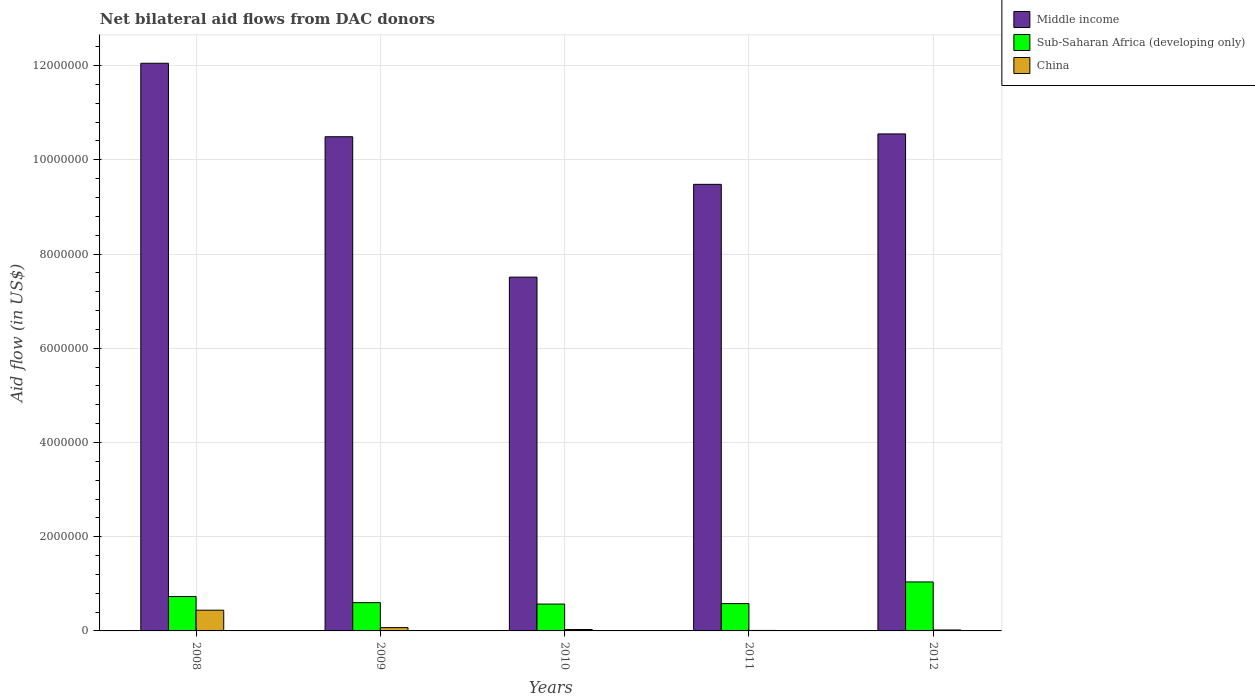Are the number of bars per tick equal to the number of legend labels?
Provide a short and direct response. Yes. Are the number of bars on each tick of the X-axis equal?
Ensure brevity in your answer.  Yes. How many bars are there on the 1st tick from the right?
Keep it short and to the point. 3. What is the label of the 4th group of bars from the left?
Provide a succinct answer. 2011. In how many cases, is the number of bars for a given year not equal to the number of legend labels?
Ensure brevity in your answer.  0. What is the net bilateral aid flow in Middle income in 2012?
Provide a succinct answer. 1.06e+07. Across all years, what is the maximum net bilateral aid flow in Middle income?
Your answer should be very brief. 1.20e+07. Across all years, what is the minimum net bilateral aid flow in Middle income?
Your answer should be very brief. 7.51e+06. In which year was the net bilateral aid flow in China maximum?
Your response must be concise. 2008. What is the total net bilateral aid flow in Sub-Saharan Africa (developing only) in the graph?
Offer a terse response. 3.52e+06. What is the difference between the net bilateral aid flow in Sub-Saharan Africa (developing only) in 2010 and that in 2011?
Provide a succinct answer. -10000. What is the difference between the net bilateral aid flow in China in 2010 and the net bilateral aid flow in Middle income in 2012?
Give a very brief answer. -1.05e+07. What is the average net bilateral aid flow in Middle income per year?
Make the answer very short. 1.00e+07. In the year 2011, what is the difference between the net bilateral aid flow in Sub-Saharan Africa (developing only) and net bilateral aid flow in China?
Offer a very short reply. 5.70e+05. In how many years, is the net bilateral aid flow in Sub-Saharan Africa (developing only) greater than 8400000 US$?
Give a very brief answer. 0. What is the ratio of the net bilateral aid flow in Sub-Saharan Africa (developing only) in 2010 to that in 2011?
Make the answer very short. 0.98. Is the difference between the net bilateral aid flow in Sub-Saharan Africa (developing only) in 2010 and 2011 greater than the difference between the net bilateral aid flow in China in 2010 and 2011?
Your answer should be very brief. No. What is the difference between the highest and the second highest net bilateral aid flow in Middle income?
Your answer should be compact. 1.50e+06. What is the difference between the highest and the lowest net bilateral aid flow in China?
Ensure brevity in your answer.  4.30e+05. In how many years, is the net bilateral aid flow in Sub-Saharan Africa (developing only) greater than the average net bilateral aid flow in Sub-Saharan Africa (developing only) taken over all years?
Your response must be concise. 2. Is the sum of the net bilateral aid flow in Sub-Saharan Africa (developing only) in 2008 and 2009 greater than the maximum net bilateral aid flow in China across all years?
Give a very brief answer. Yes. What does the 2nd bar from the left in 2010 represents?
Keep it short and to the point. Sub-Saharan Africa (developing only). What does the 2nd bar from the right in 2012 represents?
Your response must be concise. Sub-Saharan Africa (developing only). Is it the case that in every year, the sum of the net bilateral aid flow in Middle income and net bilateral aid flow in Sub-Saharan Africa (developing only) is greater than the net bilateral aid flow in China?
Your response must be concise. Yes. What is the difference between two consecutive major ticks on the Y-axis?
Offer a terse response. 2.00e+06. Does the graph contain any zero values?
Make the answer very short. No. Where does the legend appear in the graph?
Your answer should be very brief. Top right. How are the legend labels stacked?
Your answer should be compact. Vertical. What is the title of the graph?
Offer a very short reply. Net bilateral aid flows from DAC donors. What is the label or title of the Y-axis?
Your answer should be very brief. Aid flow (in US$). What is the Aid flow (in US$) of Middle income in 2008?
Keep it short and to the point. 1.20e+07. What is the Aid flow (in US$) of Sub-Saharan Africa (developing only) in 2008?
Provide a succinct answer. 7.30e+05. What is the Aid flow (in US$) in China in 2008?
Your response must be concise. 4.40e+05. What is the Aid flow (in US$) in Middle income in 2009?
Offer a very short reply. 1.05e+07. What is the Aid flow (in US$) in Sub-Saharan Africa (developing only) in 2009?
Make the answer very short. 6.00e+05. What is the Aid flow (in US$) in Middle income in 2010?
Give a very brief answer. 7.51e+06. What is the Aid flow (in US$) in Sub-Saharan Africa (developing only) in 2010?
Provide a short and direct response. 5.70e+05. What is the Aid flow (in US$) in China in 2010?
Ensure brevity in your answer.  3.00e+04. What is the Aid flow (in US$) in Middle income in 2011?
Ensure brevity in your answer.  9.48e+06. What is the Aid flow (in US$) in Sub-Saharan Africa (developing only) in 2011?
Make the answer very short. 5.80e+05. What is the Aid flow (in US$) in Middle income in 2012?
Ensure brevity in your answer.  1.06e+07. What is the Aid flow (in US$) in Sub-Saharan Africa (developing only) in 2012?
Offer a terse response. 1.04e+06. Across all years, what is the maximum Aid flow (in US$) of Middle income?
Give a very brief answer. 1.20e+07. Across all years, what is the maximum Aid flow (in US$) of Sub-Saharan Africa (developing only)?
Keep it short and to the point. 1.04e+06. Across all years, what is the maximum Aid flow (in US$) of China?
Your answer should be compact. 4.40e+05. Across all years, what is the minimum Aid flow (in US$) in Middle income?
Offer a very short reply. 7.51e+06. Across all years, what is the minimum Aid flow (in US$) in Sub-Saharan Africa (developing only)?
Provide a succinct answer. 5.70e+05. Across all years, what is the minimum Aid flow (in US$) of China?
Ensure brevity in your answer.  10000. What is the total Aid flow (in US$) of Middle income in the graph?
Your answer should be very brief. 5.01e+07. What is the total Aid flow (in US$) in Sub-Saharan Africa (developing only) in the graph?
Give a very brief answer. 3.52e+06. What is the total Aid flow (in US$) of China in the graph?
Ensure brevity in your answer.  5.70e+05. What is the difference between the Aid flow (in US$) in Middle income in 2008 and that in 2009?
Offer a terse response. 1.56e+06. What is the difference between the Aid flow (in US$) in Sub-Saharan Africa (developing only) in 2008 and that in 2009?
Provide a succinct answer. 1.30e+05. What is the difference between the Aid flow (in US$) in Middle income in 2008 and that in 2010?
Offer a terse response. 4.54e+06. What is the difference between the Aid flow (in US$) in Middle income in 2008 and that in 2011?
Your answer should be compact. 2.57e+06. What is the difference between the Aid flow (in US$) in Sub-Saharan Africa (developing only) in 2008 and that in 2011?
Offer a very short reply. 1.50e+05. What is the difference between the Aid flow (in US$) in China in 2008 and that in 2011?
Give a very brief answer. 4.30e+05. What is the difference between the Aid flow (in US$) of Middle income in 2008 and that in 2012?
Your answer should be very brief. 1.50e+06. What is the difference between the Aid flow (in US$) of Sub-Saharan Africa (developing only) in 2008 and that in 2012?
Your response must be concise. -3.10e+05. What is the difference between the Aid flow (in US$) in China in 2008 and that in 2012?
Provide a short and direct response. 4.20e+05. What is the difference between the Aid flow (in US$) of Middle income in 2009 and that in 2010?
Keep it short and to the point. 2.98e+06. What is the difference between the Aid flow (in US$) of Middle income in 2009 and that in 2011?
Give a very brief answer. 1.01e+06. What is the difference between the Aid flow (in US$) of Sub-Saharan Africa (developing only) in 2009 and that in 2011?
Make the answer very short. 2.00e+04. What is the difference between the Aid flow (in US$) in Sub-Saharan Africa (developing only) in 2009 and that in 2012?
Your answer should be compact. -4.40e+05. What is the difference between the Aid flow (in US$) in China in 2009 and that in 2012?
Provide a succinct answer. 5.00e+04. What is the difference between the Aid flow (in US$) of Middle income in 2010 and that in 2011?
Your answer should be compact. -1.97e+06. What is the difference between the Aid flow (in US$) in Sub-Saharan Africa (developing only) in 2010 and that in 2011?
Offer a very short reply. -10000. What is the difference between the Aid flow (in US$) in Middle income in 2010 and that in 2012?
Your answer should be very brief. -3.04e+06. What is the difference between the Aid flow (in US$) in Sub-Saharan Africa (developing only) in 2010 and that in 2012?
Provide a succinct answer. -4.70e+05. What is the difference between the Aid flow (in US$) in China in 2010 and that in 2012?
Keep it short and to the point. 10000. What is the difference between the Aid flow (in US$) of Middle income in 2011 and that in 2012?
Your answer should be very brief. -1.07e+06. What is the difference between the Aid flow (in US$) of Sub-Saharan Africa (developing only) in 2011 and that in 2012?
Ensure brevity in your answer.  -4.60e+05. What is the difference between the Aid flow (in US$) of China in 2011 and that in 2012?
Provide a short and direct response. -10000. What is the difference between the Aid flow (in US$) of Middle income in 2008 and the Aid flow (in US$) of Sub-Saharan Africa (developing only) in 2009?
Make the answer very short. 1.14e+07. What is the difference between the Aid flow (in US$) in Middle income in 2008 and the Aid flow (in US$) in China in 2009?
Your answer should be compact. 1.20e+07. What is the difference between the Aid flow (in US$) in Sub-Saharan Africa (developing only) in 2008 and the Aid flow (in US$) in China in 2009?
Make the answer very short. 6.60e+05. What is the difference between the Aid flow (in US$) in Middle income in 2008 and the Aid flow (in US$) in Sub-Saharan Africa (developing only) in 2010?
Offer a terse response. 1.15e+07. What is the difference between the Aid flow (in US$) of Middle income in 2008 and the Aid flow (in US$) of China in 2010?
Make the answer very short. 1.20e+07. What is the difference between the Aid flow (in US$) in Sub-Saharan Africa (developing only) in 2008 and the Aid flow (in US$) in China in 2010?
Ensure brevity in your answer.  7.00e+05. What is the difference between the Aid flow (in US$) of Middle income in 2008 and the Aid flow (in US$) of Sub-Saharan Africa (developing only) in 2011?
Give a very brief answer. 1.15e+07. What is the difference between the Aid flow (in US$) in Middle income in 2008 and the Aid flow (in US$) in China in 2011?
Your response must be concise. 1.20e+07. What is the difference between the Aid flow (in US$) of Sub-Saharan Africa (developing only) in 2008 and the Aid flow (in US$) of China in 2011?
Keep it short and to the point. 7.20e+05. What is the difference between the Aid flow (in US$) in Middle income in 2008 and the Aid flow (in US$) in Sub-Saharan Africa (developing only) in 2012?
Your response must be concise. 1.10e+07. What is the difference between the Aid flow (in US$) in Middle income in 2008 and the Aid flow (in US$) in China in 2012?
Provide a succinct answer. 1.20e+07. What is the difference between the Aid flow (in US$) of Sub-Saharan Africa (developing only) in 2008 and the Aid flow (in US$) of China in 2012?
Your response must be concise. 7.10e+05. What is the difference between the Aid flow (in US$) of Middle income in 2009 and the Aid flow (in US$) of Sub-Saharan Africa (developing only) in 2010?
Keep it short and to the point. 9.92e+06. What is the difference between the Aid flow (in US$) in Middle income in 2009 and the Aid flow (in US$) in China in 2010?
Your response must be concise. 1.05e+07. What is the difference between the Aid flow (in US$) in Sub-Saharan Africa (developing only) in 2009 and the Aid flow (in US$) in China in 2010?
Provide a succinct answer. 5.70e+05. What is the difference between the Aid flow (in US$) of Middle income in 2009 and the Aid flow (in US$) of Sub-Saharan Africa (developing only) in 2011?
Provide a short and direct response. 9.91e+06. What is the difference between the Aid flow (in US$) in Middle income in 2009 and the Aid flow (in US$) in China in 2011?
Provide a succinct answer. 1.05e+07. What is the difference between the Aid flow (in US$) in Sub-Saharan Africa (developing only) in 2009 and the Aid flow (in US$) in China in 2011?
Give a very brief answer. 5.90e+05. What is the difference between the Aid flow (in US$) in Middle income in 2009 and the Aid flow (in US$) in Sub-Saharan Africa (developing only) in 2012?
Provide a succinct answer. 9.45e+06. What is the difference between the Aid flow (in US$) of Middle income in 2009 and the Aid flow (in US$) of China in 2012?
Your answer should be compact. 1.05e+07. What is the difference between the Aid flow (in US$) of Sub-Saharan Africa (developing only) in 2009 and the Aid flow (in US$) of China in 2012?
Your response must be concise. 5.80e+05. What is the difference between the Aid flow (in US$) in Middle income in 2010 and the Aid flow (in US$) in Sub-Saharan Africa (developing only) in 2011?
Keep it short and to the point. 6.93e+06. What is the difference between the Aid flow (in US$) of Middle income in 2010 and the Aid flow (in US$) of China in 2011?
Your response must be concise. 7.50e+06. What is the difference between the Aid flow (in US$) of Sub-Saharan Africa (developing only) in 2010 and the Aid flow (in US$) of China in 2011?
Make the answer very short. 5.60e+05. What is the difference between the Aid flow (in US$) in Middle income in 2010 and the Aid flow (in US$) in Sub-Saharan Africa (developing only) in 2012?
Give a very brief answer. 6.47e+06. What is the difference between the Aid flow (in US$) of Middle income in 2010 and the Aid flow (in US$) of China in 2012?
Offer a terse response. 7.49e+06. What is the difference between the Aid flow (in US$) in Sub-Saharan Africa (developing only) in 2010 and the Aid flow (in US$) in China in 2012?
Provide a succinct answer. 5.50e+05. What is the difference between the Aid flow (in US$) in Middle income in 2011 and the Aid flow (in US$) in Sub-Saharan Africa (developing only) in 2012?
Provide a succinct answer. 8.44e+06. What is the difference between the Aid flow (in US$) in Middle income in 2011 and the Aid flow (in US$) in China in 2012?
Provide a succinct answer. 9.46e+06. What is the difference between the Aid flow (in US$) of Sub-Saharan Africa (developing only) in 2011 and the Aid flow (in US$) of China in 2012?
Give a very brief answer. 5.60e+05. What is the average Aid flow (in US$) in Middle income per year?
Give a very brief answer. 1.00e+07. What is the average Aid flow (in US$) in Sub-Saharan Africa (developing only) per year?
Give a very brief answer. 7.04e+05. What is the average Aid flow (in US$) in China per year?
Ensure brevity in your answer.  1.14e+05. In the year 2008, what is the difference between the Aid flow (in US$) of Middle income and Aid flow (in US$) of Sub-Saharan Africa (developing only)?
Offer a very short reply. 1.13e+07. In the year 2008, what is the difference between the Aid flow (in US$) in Middle income and Aid flow (in US$) in China?
Ensure brevity in your answer.  1.16e+07. In the year 2008, what is the difference between the Aid flow (in US$) in Sub-Saharan Africa (developing only) and Aid flow (in US$) in China?
Your answer should be very brief. 2.90e+05. In the year 2009, what is the difference between the Aid flow (in US$) in Middle income and Aid flow (in US$) in Sub-Saharan Africa (developing only)?
Offer a terse response. 9.89e+06. In the year 2009, what is the difference between the Aid flow (in US$) of Middle income and Aid flow (in US$) of China?
Provide a succinct answer. 1.04e+07. In the year 2009, what is the difference between the Aid flow (in US$) in Sub-Saharan Africa (developing only) and Aid flow (in US$) in China?
Make the answer very short. 5.30e+05. In the year 2010, what is the difference between the Aid flow (in US$) in Middle income and Aid flow (in US$) in Sub-Saharan Africa (developing only)?
Make the answer very short. 6.94e+06. In the year 2010, what is the difference between the Aid flow (in US$) of Middle income and Aid flow (in US$) of China?
Provide a succinct answer. 7.48e+06. In the year 2010, what is the difference between the Aid flow (in US$) of Sub-Saharan Africa (developing only) and Aid flow (in US$) of China?
Your response must be concise. 5.40e+05. In the year 2011, what is the difference between the Aid flow (in US$) of Middle income and Aid flow (in US$) of Sub-Saharan Africa (developing only)?
Keep it short and to the point. 8.90e+06. In the year 2011, what is the difference between the Aid flow (in US$) of Middle income and Aid flow (in US$) of China?
Provide a succinct answer. 9.47e+06. In the year 2011, what is the difference between the Aid flow (in US$) of Sub-Saharan Africa (developing only) and Aid flow (in US$) of China?
Make the answer very short. 5.70e+05. In the year 2012, what is the difference between the Aid flow (in US$) in Middle income and Aid flow (in US$) in Sub-Saharan Africa (developing only)?
Your response must be concise. 9.51e+06. In the year 2012, what is the difference between the Aid flow (in US$) of Middle income and Aid flow (in US$) of China?
Offer a terse response. 1.05e+07. In the year 2012, what is the difference between the Aid flow (in US$) in Sub-Saharan Africa (developing only) and Aid flow (in US$) in China?
Provide a short and direct response. 1.02e+06. What is the ratio of the Aid flow (in US$) in Middle income in 2008 to that in 2009?
Your answer should be compact. 1.15. What is the ratio of the Aid flow (in US$) in Sub-Saharan Africa (developing only) in 2008 to that in 2009?
Your answer should be very brief. 1.22. What is the ratio of the Aid flow (in US$) in China in 2008 to that in 2009?
Offer a terse response. 6.29. What is the ratio of the Aid flow (in US$) of Middle income in 2008 to that in 2010?
Keep it short and to the point. 1.6. What is the ratio of the Aid flow (in US$) in Sub-Saharan Africa (developing only) in 2008 to that in 2010?
Provide a short and direct response. 1.28. What is the ratio of the Aid flow (in US$) in China in 2008 to that in 2010?
Provide a short and direct response. 14.67. What is the ratio of the Aid flow (in US$) of Middle income in 2008 to that in 2011?
Your response must be concise. 1.27. What is the ratio of the Aid flow (in US$) in Sub-Saharan Africa (developing only) in 2008 to that in 2011?
Give a very brief answer. 1.26. What is the ratio of the Aid flow (in US$) in Middle income in 2008 to that in 2012?
Offer a terse response. 1.14. What is the ratio of the Aid flow (in US$) in Sub-Saharan Africa (developing only) in 2008 to that in 2012?
Provide a short and direct response. 0.7. What is the ratio of the Aid flow (in US$) in Middle income in 2009 to that in 2010?
Make the answer very short. 1.4. What is the ratio of the Aid flow (in US$) in Sub-Saharan Africa (developing only) in 2009 to that in 2010?
Your answer should be compact. 1.05. What is the ratio of the Aid flow (in US$) of China in 2009 to that in 2010?
Your answer should be compact. 2.33. What is the ratio of the Aid flow (in US$) of Middle income in 2009 to that in 2011?
Provide a short and direct response. 1.11. What is the ratio of the Aid flow (in US$) in Sub-Saharan Africa (developing only) in 2009 to that in 2011?
Offer a very short reply. 1.03. What is the ratio of the Aid flow (in US$) in China in 2009 to that in 2011?
Provide a succinct answer. 7. What is the ratio of the Aid flow (in US$) of Sub-Saharan Africa (developing only) in 2009 to that in 2012?
Your response must be concise. 0.58. What is the ratio of the Aid flow (in US$) in China in 2009 to that in 2012?
Provide a short and direct response. 3.5. What is the ratio of the Aid flow (in US$) in Middle income in 2010 to that in 2011?
Your response must be concise. 0.79. What is the ratio of the Aid flow (in US$) of Sub-Saharan Africa (developing only) in 2010 to that in 2011?
Provide a short and direct response. 0.98. What is the ratio of the Aid flow (in US$) of China in 2010 to that in 2011?
Provide a short and direct response. 3. What is the ratio of the Aid flow (in US$) of Middle income in 2010 to that in 2012?
Give a very brief answer. 0.71. What is the ratio of the Aid flow (in US$) in Sub-Saharan Africa (developing only) in 2010 to that in 2012?
Provide a succinct answer. 0.55. What is the ratio of the Aid flow (in US$) of Middle income in 2011 to that in 2012?
Your answer should be compact. 0.9. What is the ratio of the Aid flow (in US$) of Sub-Saharan Africa (developing only) in 2011 to that in 2012?
Offer a terse response. 0.56. What is the ratio of the Aid flow (in US$) in China in 2011 to that in 2012?
Offer a very short reply. 0.5. What is the difference between the highest and the second highest Aid flow (in US$) of Middle income?
Your response must be concise. 1.50e+06. What is the difference between the highest and the second highest Aid flow (in US$) in Sub-Saharan Africa (developing only)?
Your answer should be very brief. 3.10e+05. What is the difference between the highest and the second highest Aid flow (in US$) of China?
Provide a short and direct response. 3.70e+05. What is the difference between the highest and the lowest Aid flow (in US$) of Middle income?
Your answer should be compact. 4.54e+06. What is the difference between the highest and the lowest Aid flow (in US$) of China?
Provide a short and direct response. 4.30e+05. 